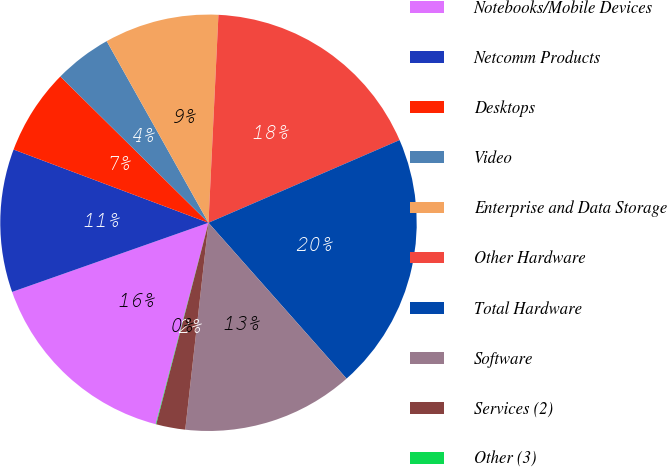<chart> <loc_0><loc_0><loc_500><loc_500><pie_chart><fcel>Notebooks/Mobile Devices<fcel>Netcomm Products<fcel>Desktops<fcel>Video<fcel>Enterprise and Data Storage<fcel>Other Hardware<fcel>Total Hardware<fcel>Software<fcel>Services (2)<fcel>Other (3)<nl><fcel>15.53%<fcel>11.11%<fcel>6.68%<fcel>4.47%<fcel>8.89%<fcel>17.74%<fcel>19.96%<fcel>13.32%<fcel>2.26%<fcel>0.04%<nl></chart> 